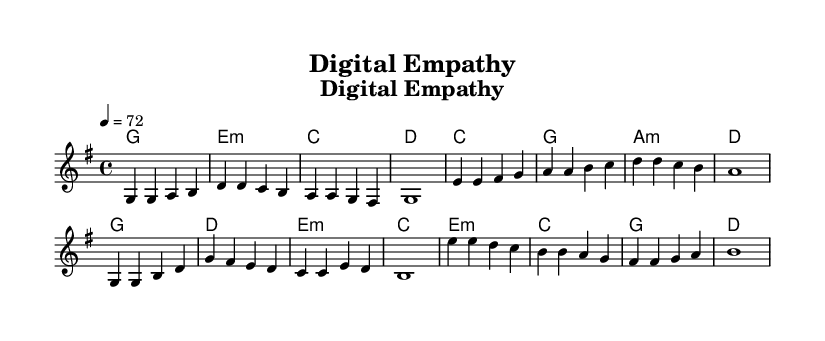What is the key signature of this music? The key signature is G major, which has one sharp (F#). This is indicated at the beginning of the staff in the key signature section.
Answer: G major What is the time signature of this music? The time signature is 4/4, commonly referred to as four-four time, which means there are four beats in a measure. This is shown at the beginning of the score after the key signature.
Answer: 4/4 What is the tempo marking for this piece? The tempo marking is crotchet = 72, indicating the speed at which the piece should be played. This is indicated in the tempo text at the start of the music.
Answer: 72 How many sections does the composition have? The composition has four distinct sections: verse, prechorus, chorus, and bridge. Each section is labeled distinctly in the sheet music, which helps identify them.
Answer: Four What chord follows the first line of the verse? The chord that follows the first line of the verse is G major. This can be seen in the chord symbols written above the lyrics, indicating the chord to be played with the verse melody.
Answer: G What is the last lyric of the chorus? The last lyric of the chorus is "agree". This is found at the end of the chorus lyrics, where all the lyrics are aligned with their corresponding melody notes.
Answer: agree Which section concludes the music piece? The section that concludes the music piece is the bridge. It serves as a closing section before the final resolution of the composition and is the last labeled section in the score.
Answer: Bridge 